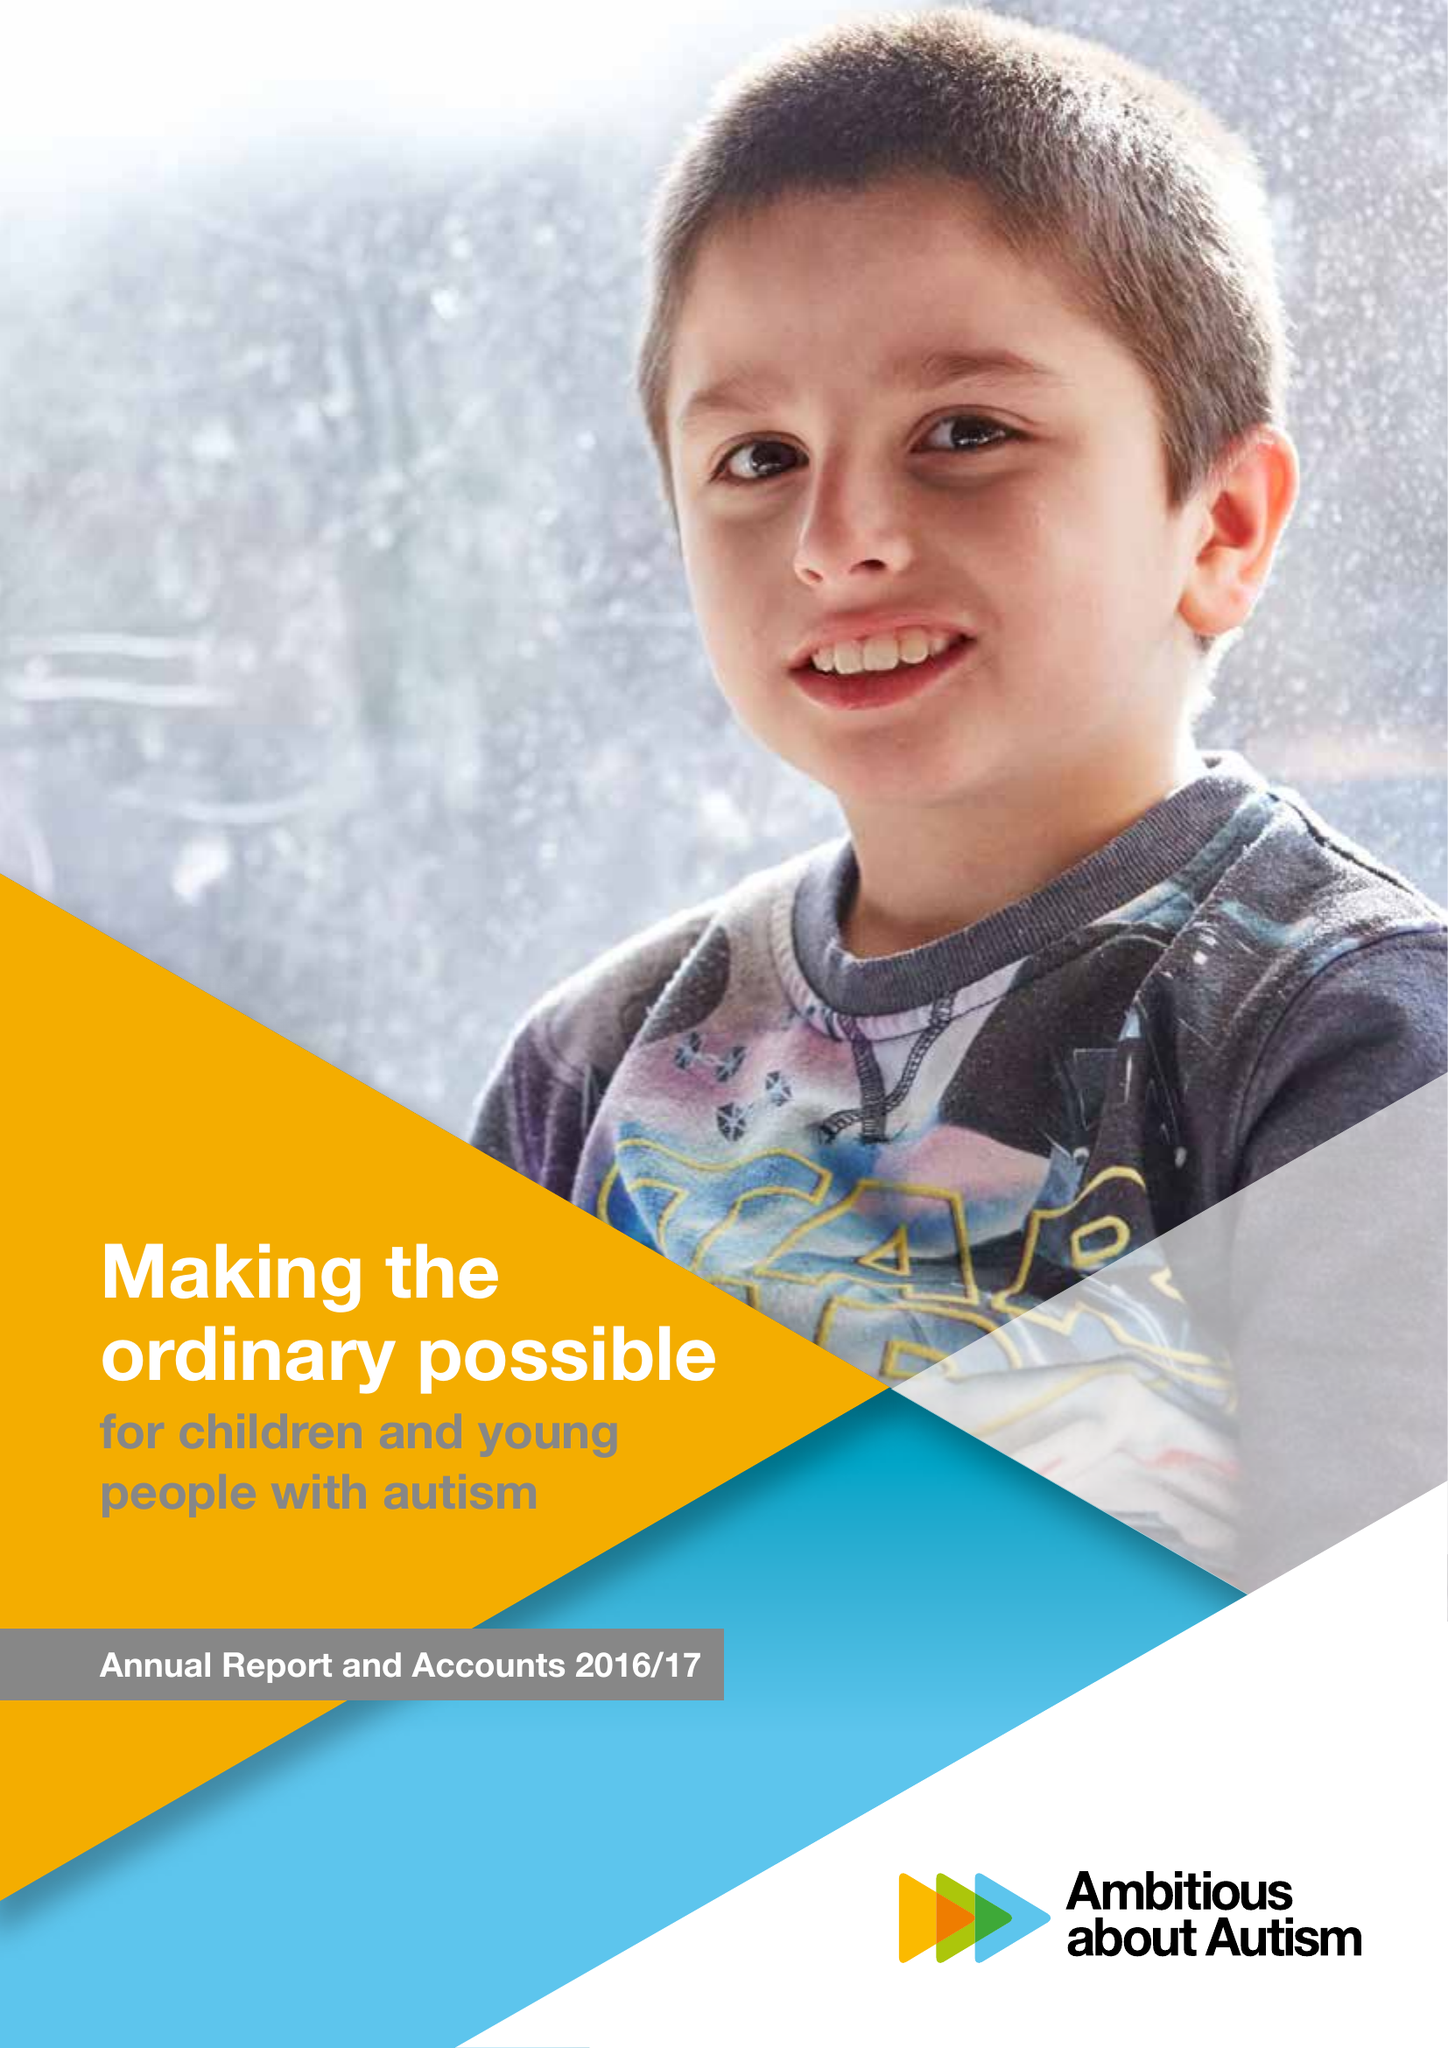What is the value for the address__post_town?
Answer the question using a single word or phrase. LONDON 